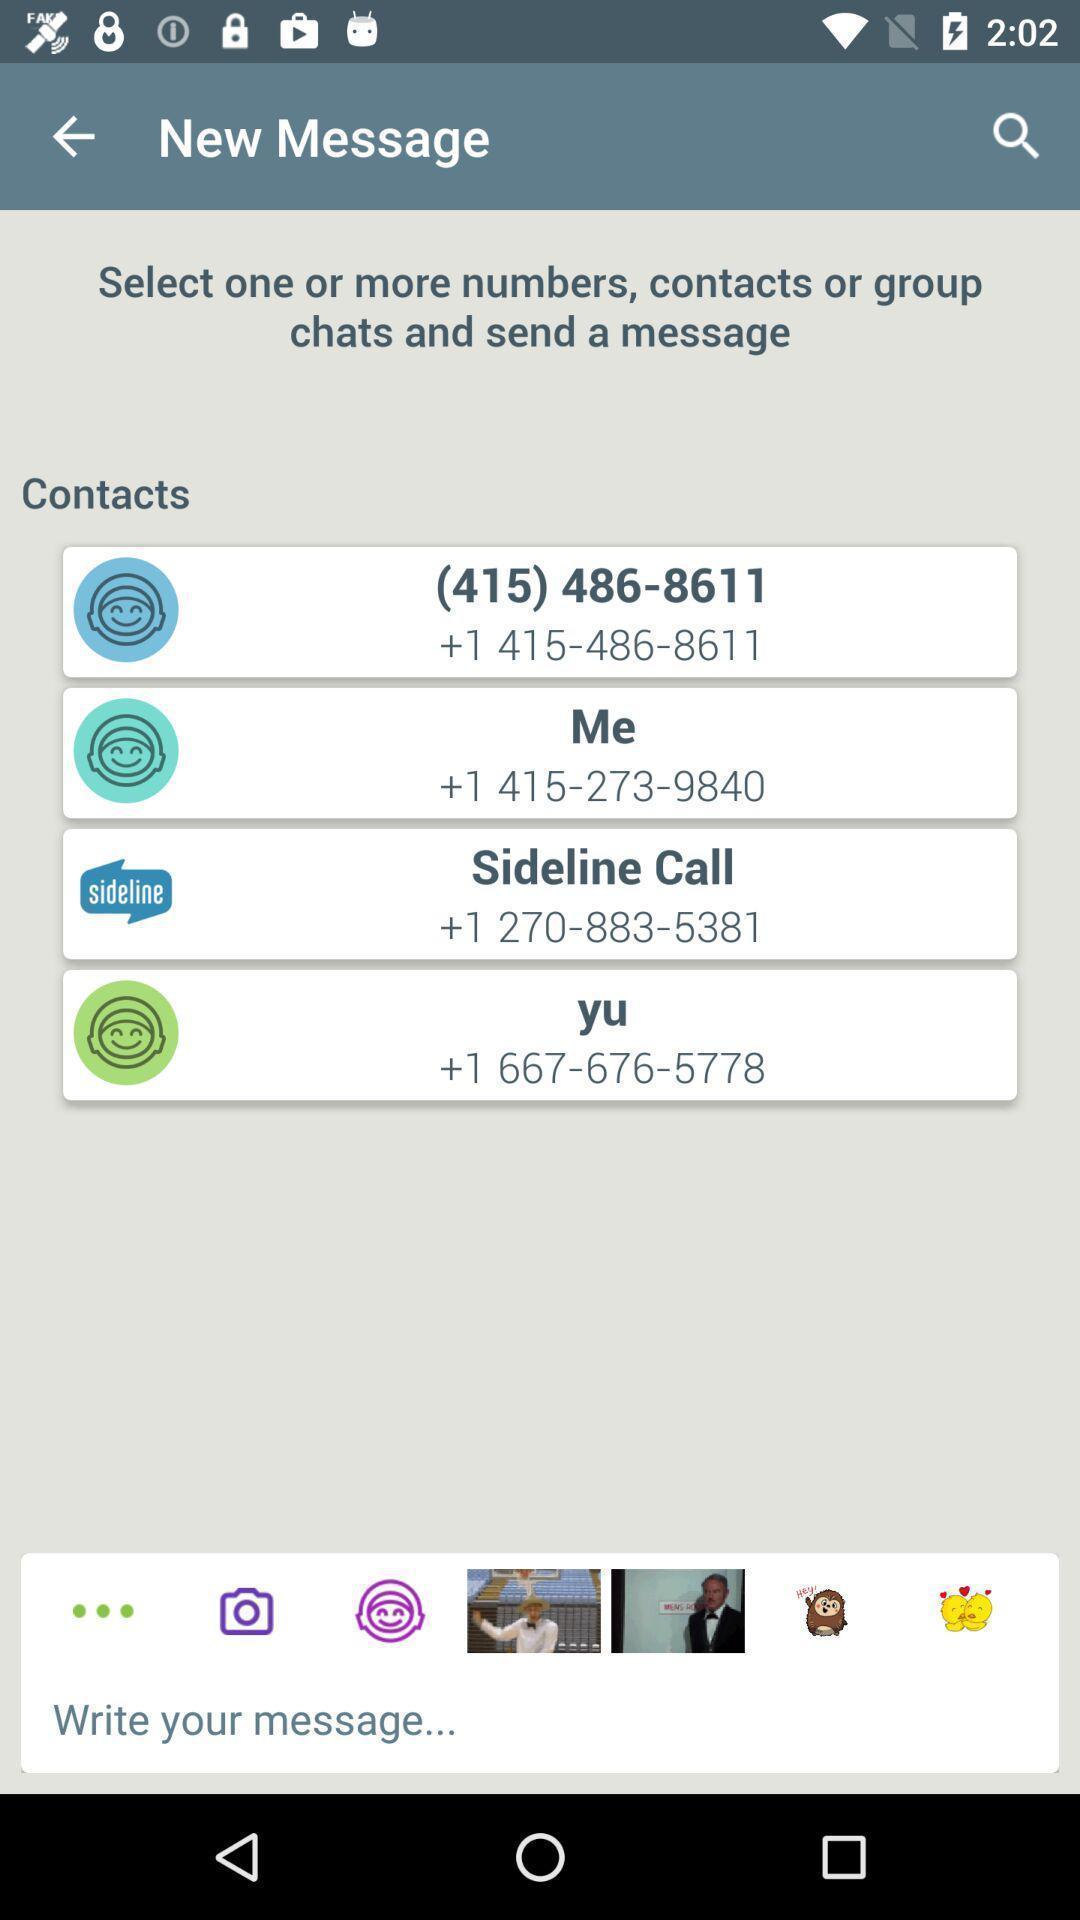Describe the key features of this screenshot. Screen showing new message with list of contacts. 